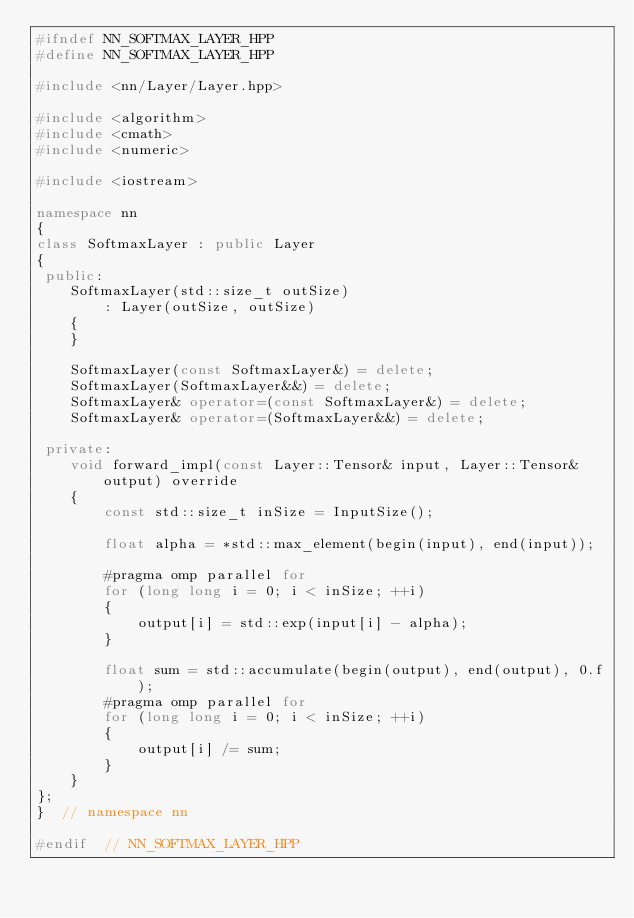<code> <loc_0><loc_0><loc_500><loc_500><_C++_>#ifndef NN_SOFTMAX_LAYER_HPP
#define NN_SOFTMAX_LAYER_HPP

#include <nn/Layer/Layer.hpp>

#include <algorithm>
#include <cmath>
#include <numeric>

#include <iostream>

namespace nn
{
class SoftmaxLayer : public Layer
{
 public:
    SoftmaxLayer(std::size_t outSize)
        : Layer(outSize, outSize)
    {
    }

    SoftmaxLayer(const SoftmaxLayer&) = delete;
    SoftmaxLayer(SoftmaxLayer&&) = delete;
    SoftmaxLayer& operator=(const SoftmaxLayer&) = delete;
    SoftmaxLayer& operator=(SoftmaxLayer&&) = delete;

 private:
    void forward_impl(const Layer::Tensor& input, Layer::Tensor& output) override
    {
        const std::size_t inSize = InputSize();

        float alpha = *std::max_element(begin(input), end(input));

        #pragma omp parallel for
        for (long long i = 0; i < inSize; ++i)
        {
            output[i] = std::exp(input[i] - alpha);
        }

        float sum = std::accumulate(begin(output), end(output), 0.f);
        #pragma omp parallel for
        for (long long i = 0; i < inSize; ++i)
        {
            output[i] /= sum;
        }
    }
};
}  // namespace nn

#endif  // NN_SOFTMAX_LAYER_HPP
</code> 